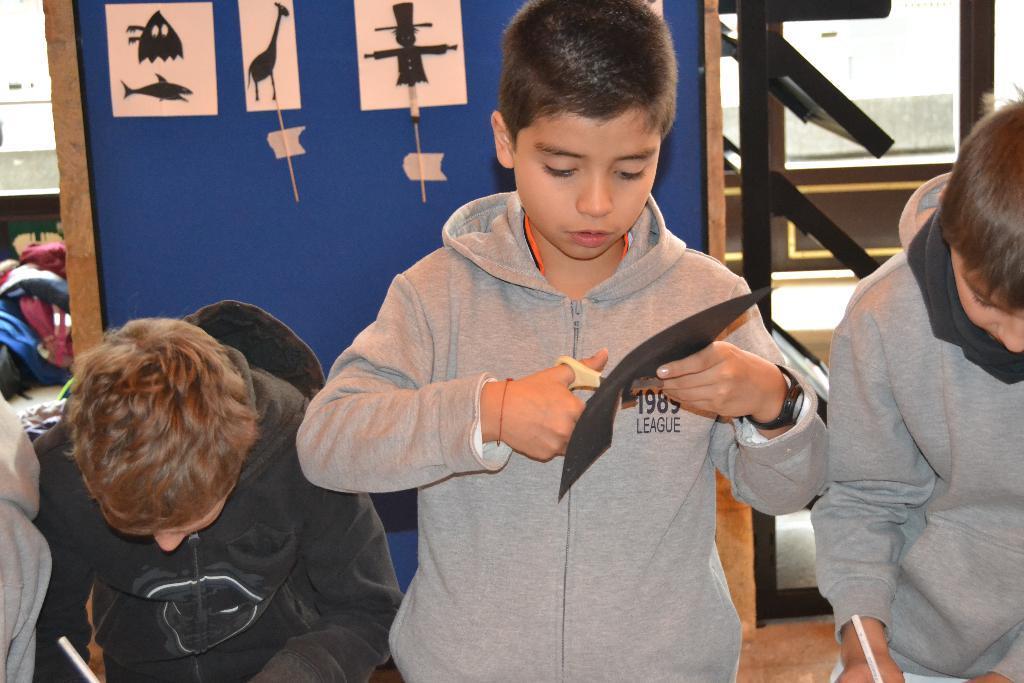How would you summarize this image in a sentence or two? In this image there are a few people standing and doing something, two are holding pens in their hands and one is holding a scissor in one hand and cutting something which is held in the other hand, behind them there is a board with some posters attached to it which is hanging on the pillar, behind the pillar there are stairs and few objects are on the floor. 